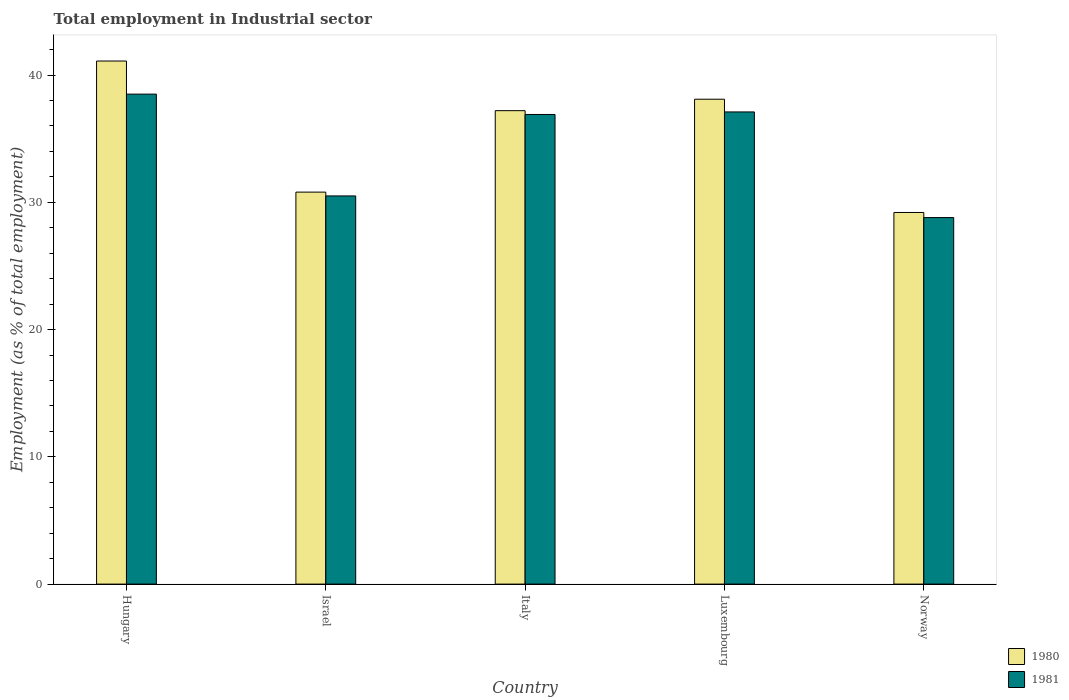Are the number of bars per tick equal to the number of legend labels?
Offer a very short reply. Yes. Are the number of bars on each tick of the X-axis equal?
Your response must be concise. Yes. What is the label of the 4th group of bars from the left?
Offer a very short reply. Luxembourg. What is the employment in industrial sector in 1981 in Italy?
Provide a succinct answer. 36.9. Across all countries, what is the maximum employment in industrial sector in 1980?
Offer a very short reply. 41.1. Across all countries, what is the minimum employment in industrial sector in 1980?
Offer a very short reply. 29.2. In which country was the employment in industrial sector in 1980 maximum?
Your answer should be very brief. Hungary. In which country was the employment in industrial sector in 1980 minimum?
Keep it short and to the point. Norway. What is the total employment in industrial sector in 1980 in the graph?
Your response must be concise. 176.4. What is the difference between the employment in industrial sector in 1981 in Hungary and the employment in industrial sector in 1980 in Italy?
Offer a very short reply. 1.3. What is the average employment in industrial sector in 1980 per country?
Ensure brevity in your answer.  35.28. What is the difference between the employment in industrial sector of/in 1981 and employment in industrial sector of/in 1980 in Norway?
Provide a short and direct response. -0.4. What is the ratio of the employment in industrial sector in 1980 in Hungary to that in Italy?
Make the answer very short. 1.1. Is the difference between the employment in industrial sector in 1981 in Italy and Norway greater than the difference between the employment in industrial sector in 1980 in Italy and Norway?
Your response must be concise. Yes. What is the difference between the highest and the second highest employment in industrial sector in 1981?
Offer a terse response. -0.2. What is the difference between the highest and the lowest employment in industrial sector in 1980?
Ensure brevity in your answer.  11.9. Is the sum of the employment in industrial sector in 1980 in Israel and Norway greater than the maximum employment in industrial sector in 1981 across all countries?
Provide a short and direct response. Yes. What is the difference between two consecutive major ticks on the Y-axis?
Keep it short and to the point. 10. Does the graph contain any zero values?
Keep it short and to the point. No. How many legend labels are there?
Provide a succinct answer. 2. What is the title of the graph?
Your answer should be compact. Total employment in Industrial sector. What is the label or title of the X-axis?
Your response must be concise. Country. What is the label or title of the Y-axis?
Keep it short and to the point. Employment (as % of total employment). What is the Employment (as % of total employment) of 1980 in Hungary?
Your answer should be compact. 41.1. What is the Employment (as % of total employment) in 1981 in Hungary?
Ensure brevity in your answer.  38.5. What is the Employment (as % of total employment) in 1980 in Israel?
Ensure brevity in your answer.  30.8. What is the Employment (as % of total employment) of 1981 in Israel?
Your response must be concise. 30.5. What is the Employment (as % of total employment) of 1980 in Italy?
Your answer should be compact. 37.2. What is the Employment (as % of total employment) of 1981 in Italy?
Provide a succinct answer. 36.9. What is the Employment (as % of total employment) in 1980 in Luxembourg?
Your answer should be compact. 38.1. What is the Employment (as % of total employment) of 1981 in Luxembourg?
Offer a terse response. 37.1. What is the Employment (as % of total employment) of 1980 in Norway?
Make the answer very short. 29.2. What is the Employment (as % of total employment) of 1981 in Norway?
Provide a succinct answer. 28.8. Across all countries, what is the maximum Employment (as % of total employment) in 1980?
Your response must be concise. 41.1. Across all countries, what is the maximum Employment (as % of total employment) in 1981?
Your response must be concise. 38.5. Across all countries, what is the minimum Employment (as % of total employment) in 1980?
Ensure brevity in your answer.  29.2. Across all countries, what is the minimum Employment (as % of total employment) in 1981?
Give a very brief answer. 28.8. What is the total Employment (as % of total employment) of 1980 in the graph?
Your response must be concise. 176.4. What is the total Employment (as % of total employment) of 1981 in the graph?
Give a very brief answer. 171.8. What is the difference between the Employment (as % of total employment) in 1980 in Hungary and that in Israel?
Offer a terse response. 10.3. What is the difference between the Employment (as % of total employment) of 1980 in Hungary and that in Italy?
Provide a short and direct response. 3.9. What is the difference between the Employment (as % of total employment) in 1981 in Hungary and that in Luxembourg?
Ensure brevity in your answer.  1.4. What is the difference between the Employment (as % of total employment) of 1981 in Hungary and that in Norway?
Your answer should be compact. 9.7. What is the difference between the Employment (as % of total employment) in 1981 in Israel and that in Italy?
Give a very brief answer. -6.4. What is the difference between the Employment (as % of total employment) of 1981 in Italy and that in Luxembourg?
Ensure brevity in your answer.  -0.2. What is the difference between the Employment (as % of total employment) in 1980 in Luxembourg and that in Norway?
Keep it short and to the point. 8.9. What is the difference between the Employment (as % of total employment) of 1980 in Hungary and the Employment (as % of total employment) of 1981 in Israel?
Your answer should be compact. 10.6. What is the difference between the Employment (as % of total employment) of 1980 in Hungary and the Employment (as % of total employment) of 1981 in Italy?
Provide a short and direct response. 4.2. What is the difference between the Employment (as % of total employment) of 1980 in Israel and the Employment (as % of total employment) of 1981 in Italy?
Offer a very short reply. -6.1. What is the difference between the Employment (as % of total employment) of 1980 in Israel and the Employment (as % of total employment) of 1981 in Norway?
Give a very brief answer. 2. What is the difference between the Employment (as % of total employment) in 1980 in Italy and the Employment (as % of total employment) in 1981 in Luxembourg?
Offer a very short reply. 0.1. What is the difference between the Employment (as % of total employment) in 1980 in Luxembourg and the Employment (as % of total employment) in 1981 in Norway?
Offer a very short reply. 9.3. What is the average Employment (as % of total employment) in 1980 per country?
Provide a short and direct response. 35.28. What is the average Employment (as % of total employment) in 1981 per country?
Provide a succinct answer. 34.36. What is the difference between the Employment (as % of total employment) of 1980 and Employment (as % of total employment) of 1981 in Israel?
Offer a very short reply. 0.3. What is the difference between the Employment (as % of total employment) of 1980 and Employment (as % of total employment) of 1981 in Italy?
Offer a very short reply. 0.3. What is the difference between the Employment (as % of total employment) in 1980 and Employment (as % of total employment) in 1981 in Luxembourg?
Provide a succinct answer. 1. What is the difference between the Employment (as % of total employment) of 1980 and Employment (as % of total employment) of 1981 in Norway?
Your response must be concise. 0.4. What is the ratio of the Employment (as % of total employment) of 1980 in Hungary to that in Israel?
Your answer should be very brief. 1.33. What is the ratio of the Employment (as % of total employment) in 1981 in Hungary to that in Israel?
Provide a short and direct response. 1.26. What is the ratio of the Employment (as % of total employment) in 1980 in Hungary to that in Italy?
Your answer should be very brief. 1.1. What is the ratio of the Employment (as % of total employment) of 1981 in Hungary to that in Italy?
Make the answer very short. 1.04. What is the ratio of the Employment (as % of total employment) of 1980 in Hungary to that in Luxembourg?
Your response must be concise. 1.08. What is the ratio of the Employment (as % of total employment) of 1981 in Hungary to that in Luxembourg?
Ensure brevity in your answer.  1.04. What is the ratio of the Employment (as % of total employment) of 1980 in Hungary to that in Norway?
Give a very brief answer. 1.41. What is the ratio of the Employment (as % of total employment) in 1981 in Hungary to that in Norway?
Provide a short and direct response. 1.34. What is the ratio of the Employment (as % of total employment) of 1980 in Israel to that in Italy?
Give a very brief answer. 0.83. What is the ratio of the Employment (as % of total employment) of 1981 in Israel to that in Italy?
Keep it short and to the point. 0.83. What is the ratio of the Employment (as % of total employment) in 1980 in Israel to that in Luxembourg?
Give a very brief answer. 0.81. What is the ratio of the Employment (as % of total employment) of 1981 in Israel to that in Luxembourg?
Make the answer very short. 0.82. What is the ratio of the Employment (as % of total employment) of 1980 in Israel to that in Norway?
Your answer should be very brief. 1.05. What is the ratio of the Employment (as % of total employment) of 1981 in Israel to that in Norway?
Ensure brevity in your answer.  1.06. What is the ratio of the Employment (as % of total employment) in 1980 in Italy to that in Luxembourg?
Ensure brevity in your answer.  0.98. What is the ratio of the Employment (as % of total employment) of 1981 in Italy to that in Luxembourg?
Make the answer very short. 0.99. What is the ratio of the Employment (as % of total employment) of 1980 in Italy to that in Norway?
Provide a short and direct response. 1.27. What is the ratio of the Employment (as % of total employment) of 1981 in Italy to that in Norway?
Give a very brief answer. 1.28. What is the ratio of the Employment (as % of total employment) of 1980 in Luxembourg to that in Norway?
Provide a succinct answer. 1.3. What is the ratio of the Employment (as % of total employment) of 1981 in Luxembourg to that in Norway?
Offer a terse response. 1.29. What is the difference between the highest and the second highest Employment (as % of total employment) of 1981?
Provide a succinct answer. 1.4. 